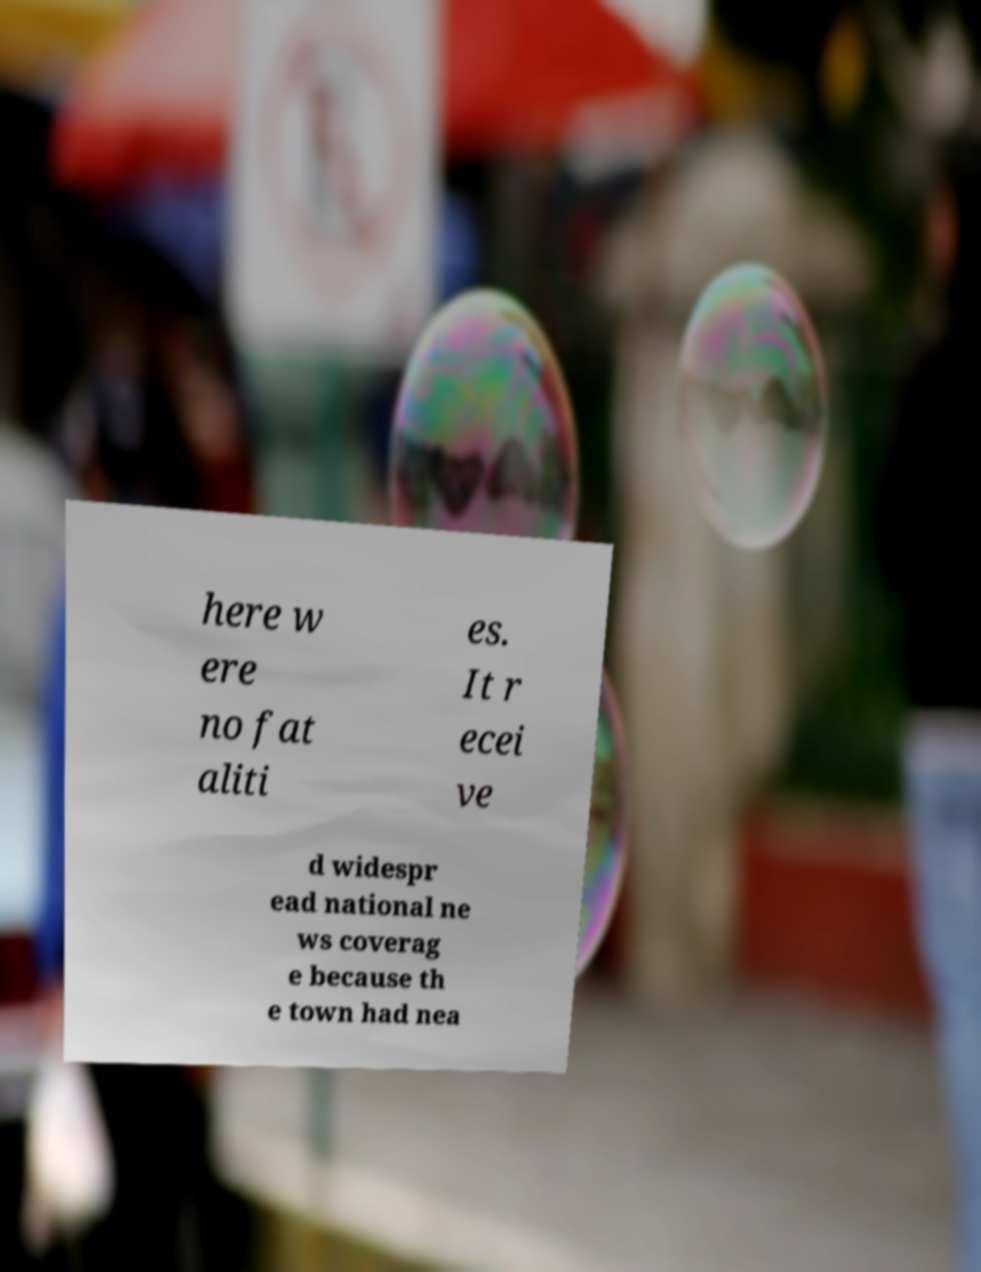I need the written content from this picture converted into text. Can you do that? here w ere no fat aliti es. It r ecei ve d widespr ead national ne ws coverag e because th e town had nea 